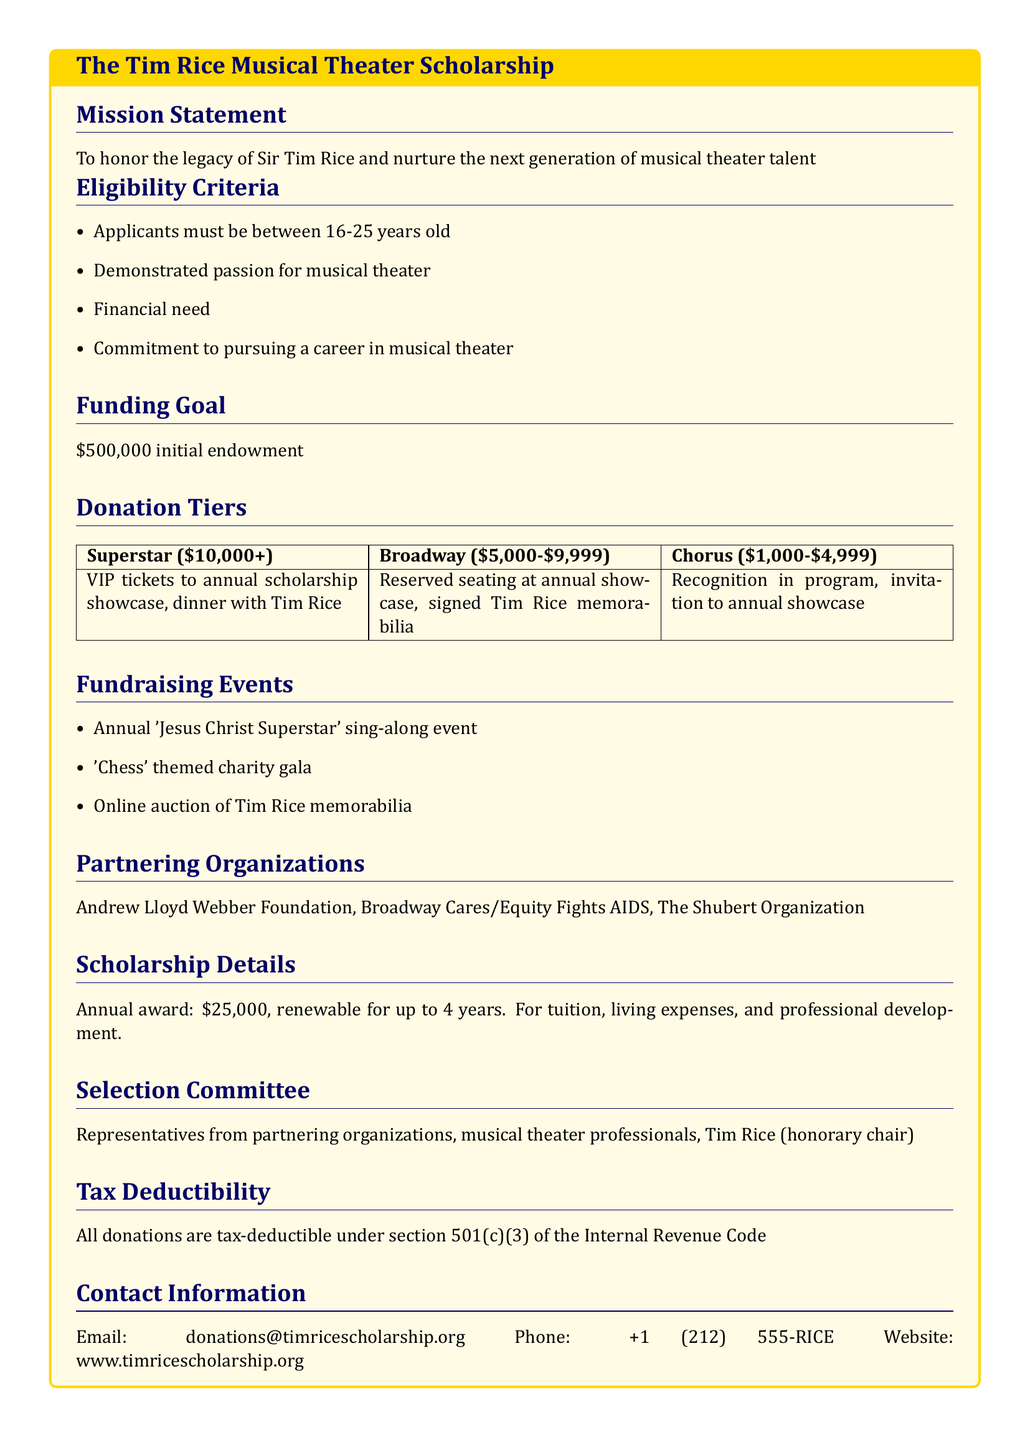What is the age range for applicants? The eligibility criteria specify that applicants must be between 16-25 years old.
Answer: 16-25 years old What is the funding goal for the scholarship program? The document states that the initial endowment goal is $500,000.
Answer: $500,000 What is the annual award amount for the scholarship? The scholarship details indicate an annual award of $25,000.
Answer: $25,000 Who serves as the honorary chair of the selection committee? The selection committee includes Tim Rice as the honorary chair.
Answer: Tim Rice What are the top donor benefits in the Superstar tier? The benefits for the Superstar tier include VIP tickets to the annual scholarship showcase and dinner with Tim Rice.
Answer: VIP tickets and dinner with Tim Rice Which organization is a partner in the fundraising efforts? The document lists the Andrew Lloyd Webber Foundation as one of the partnering organizations.
Answer: Andrew Lloyd Webber Foundation What is the tax status of donations? The document clarifies that all donations are tax-deductible under section 501(c)(3).
Answer: 501(c)(3) What type of fundraising event is mentioned that involves a sing-along? The document mentions an annual 'Jesus Christ Superstar' sing-along event as part of the fundraising events.
Answer: 'Jesus Christ Superstar' sing-along event What is the contact email for the scholarship program? The contact information section provides a specific email address for inquiries.
Answer: donations@timricescholarship.org 